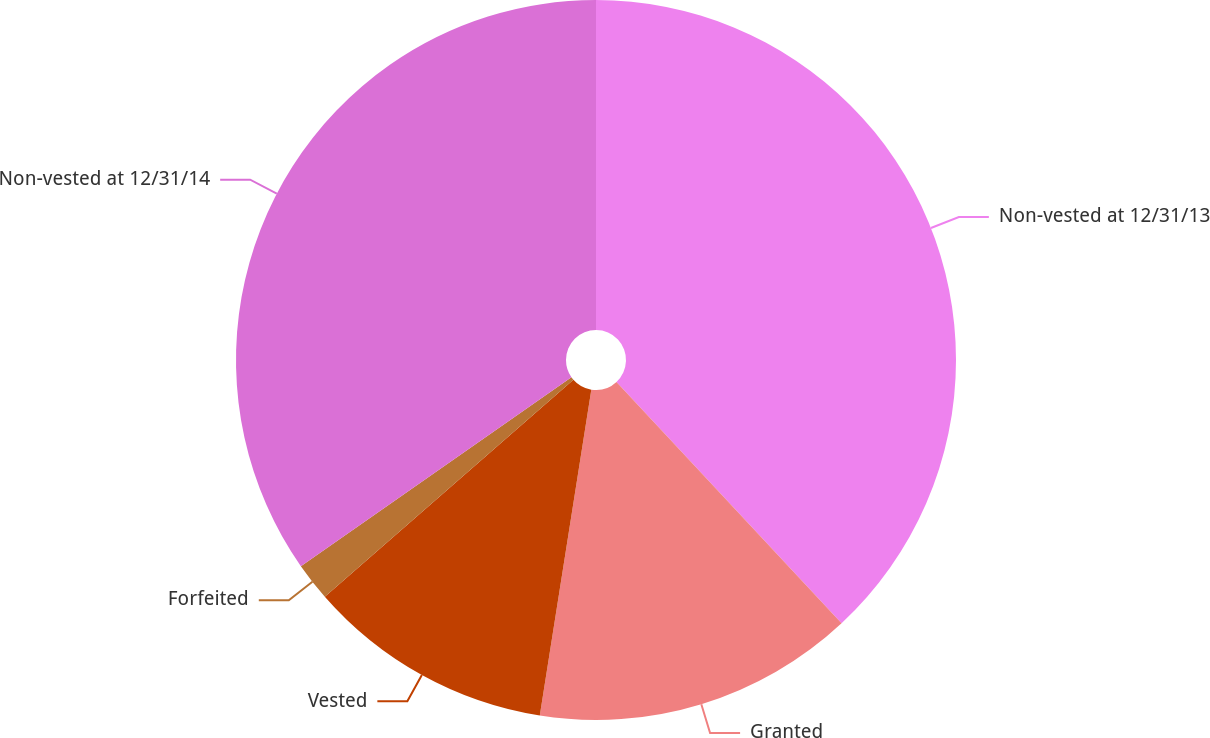Convert chart to OTSL. <chart><loc_0><loc_0><loc_500><loc_500><pie_chart><fcel>Non-vested at 12/31/13<fcel>Granted<fcel>Vested<fcel>Forfeited<fcel>Non-vested at 12/31/14<nl><fcel>38.05%<fcel>14.44%<fcel>11.08%<fcel>1.72%<fcel>34.7%<nl></chart> 